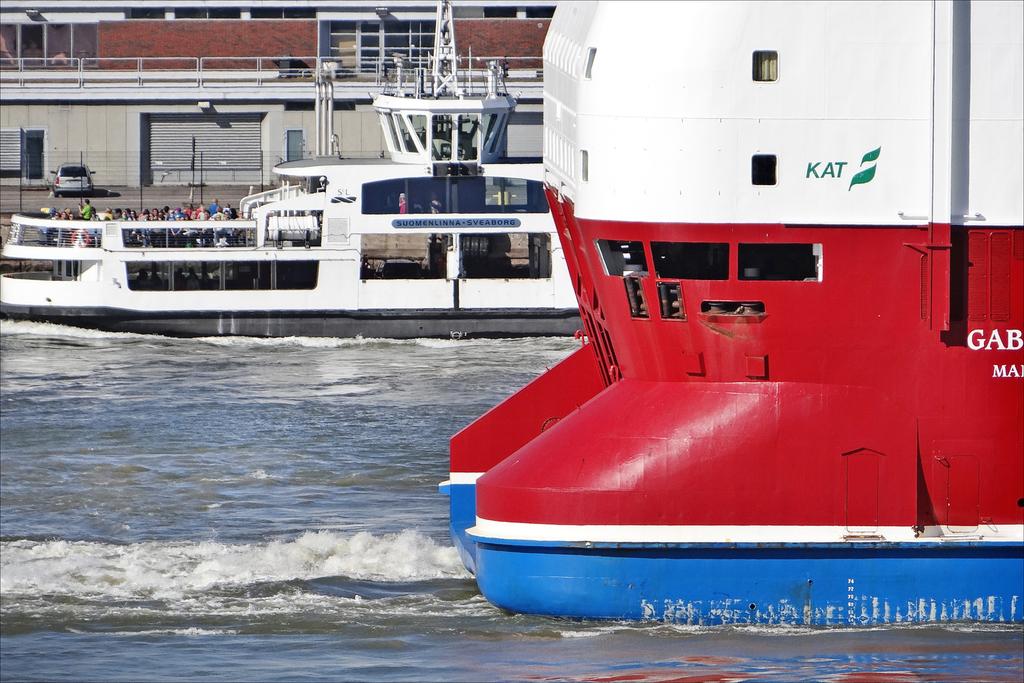What is uppermost word written on the boat in the foreground?
Provide a short and direct response. Kat. What does the logo represent on the red boat?
Give a very brief answer. Kat. 